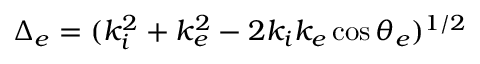Convert formula to latex. <formula><loc_0><loc_0><loc_500><loc_500>\Delta _ { e } = ( k _ { i } ^ { 2 } + k _ { e } ^ { 2 } - 2 k _ { i } k _ { e } \cos \theta _ { e } ) ^ { 1 / 2 }</formula> 